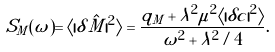Convert formula to latex. <formula><loc_0><loc_0><loc_500><loc_500>S _ { M } ( \omega ) = \langle | \delta \hat { M } | ^ { 2 } \rangle = \frac { q _ { M } + \lambda ^ { 2 } \mu ^ { 2 } \langle | \delta c | ^ { 2 } \rangle } { \omega ^ { 2 } + \lambda ^ { 2 } / 4 } .</formula> 